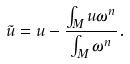Convert formula to latex. <formula><loc_0><loc_0><loc_500><loc_500>\tilde { u } = u - \frac { \int _ { M } u \omega ^ { n } } { \int _ { M } \omega ^ { n } } .</formula> 